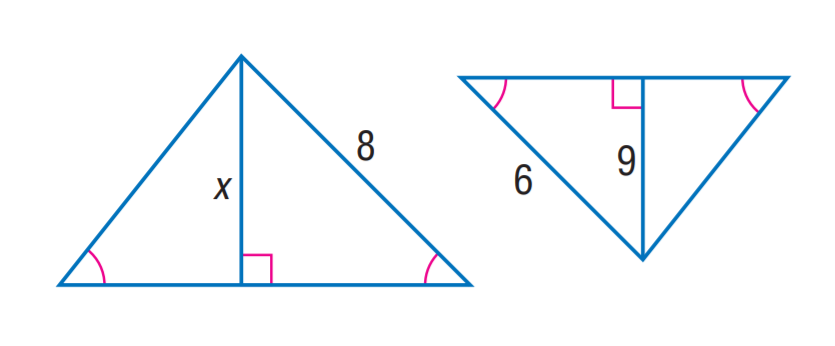Question: Find x.
Choices:
A. 6
B. 9
C. 12
D. 15
Answer with the letter. Answer: C 